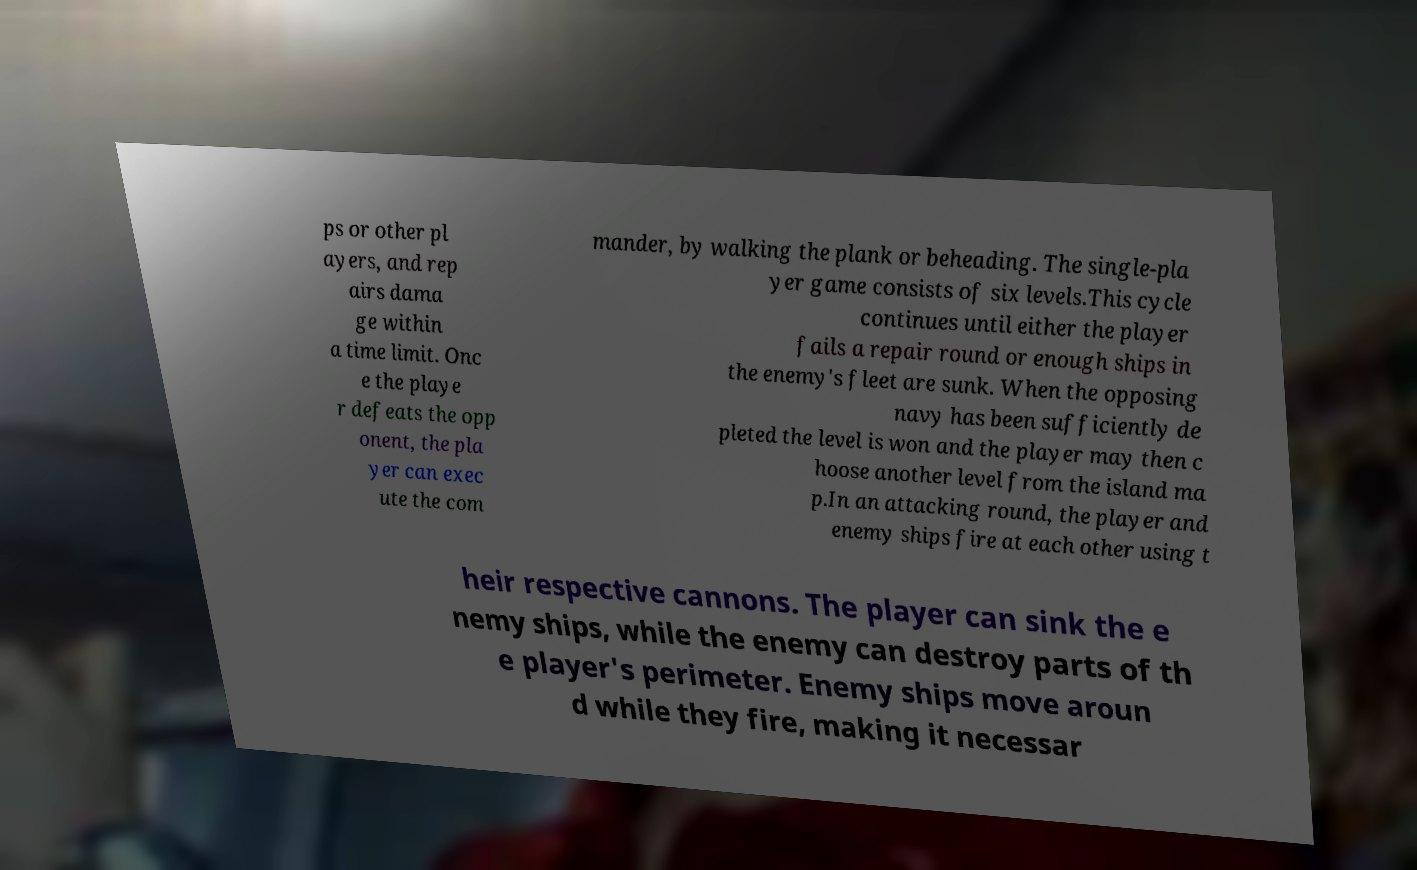Could you extract and type out the text from this image? ps or other pl ayers, and rep airs dama ge within a time limit. Onc e the playe r defeats the opp onent, the pla yer can exec ute the com mander, by walking the plank or beheading. The single-pla yer game consists of six levels.This cycle continues until either the player fails a repair round or enough ships in the enemy's fleet are sunk. When the opposing navy has been sufficiently de pleted the level is won and the player may then c hoose another level from the island ma p.In an attacking round, the player and enemy ships fire at each other using t heir respective cannons. The player can sink the e nemy ships, while the enemy can destroy parts of th e player's perimeter. Enemy ships move aroun d while they fire, making it necessar 